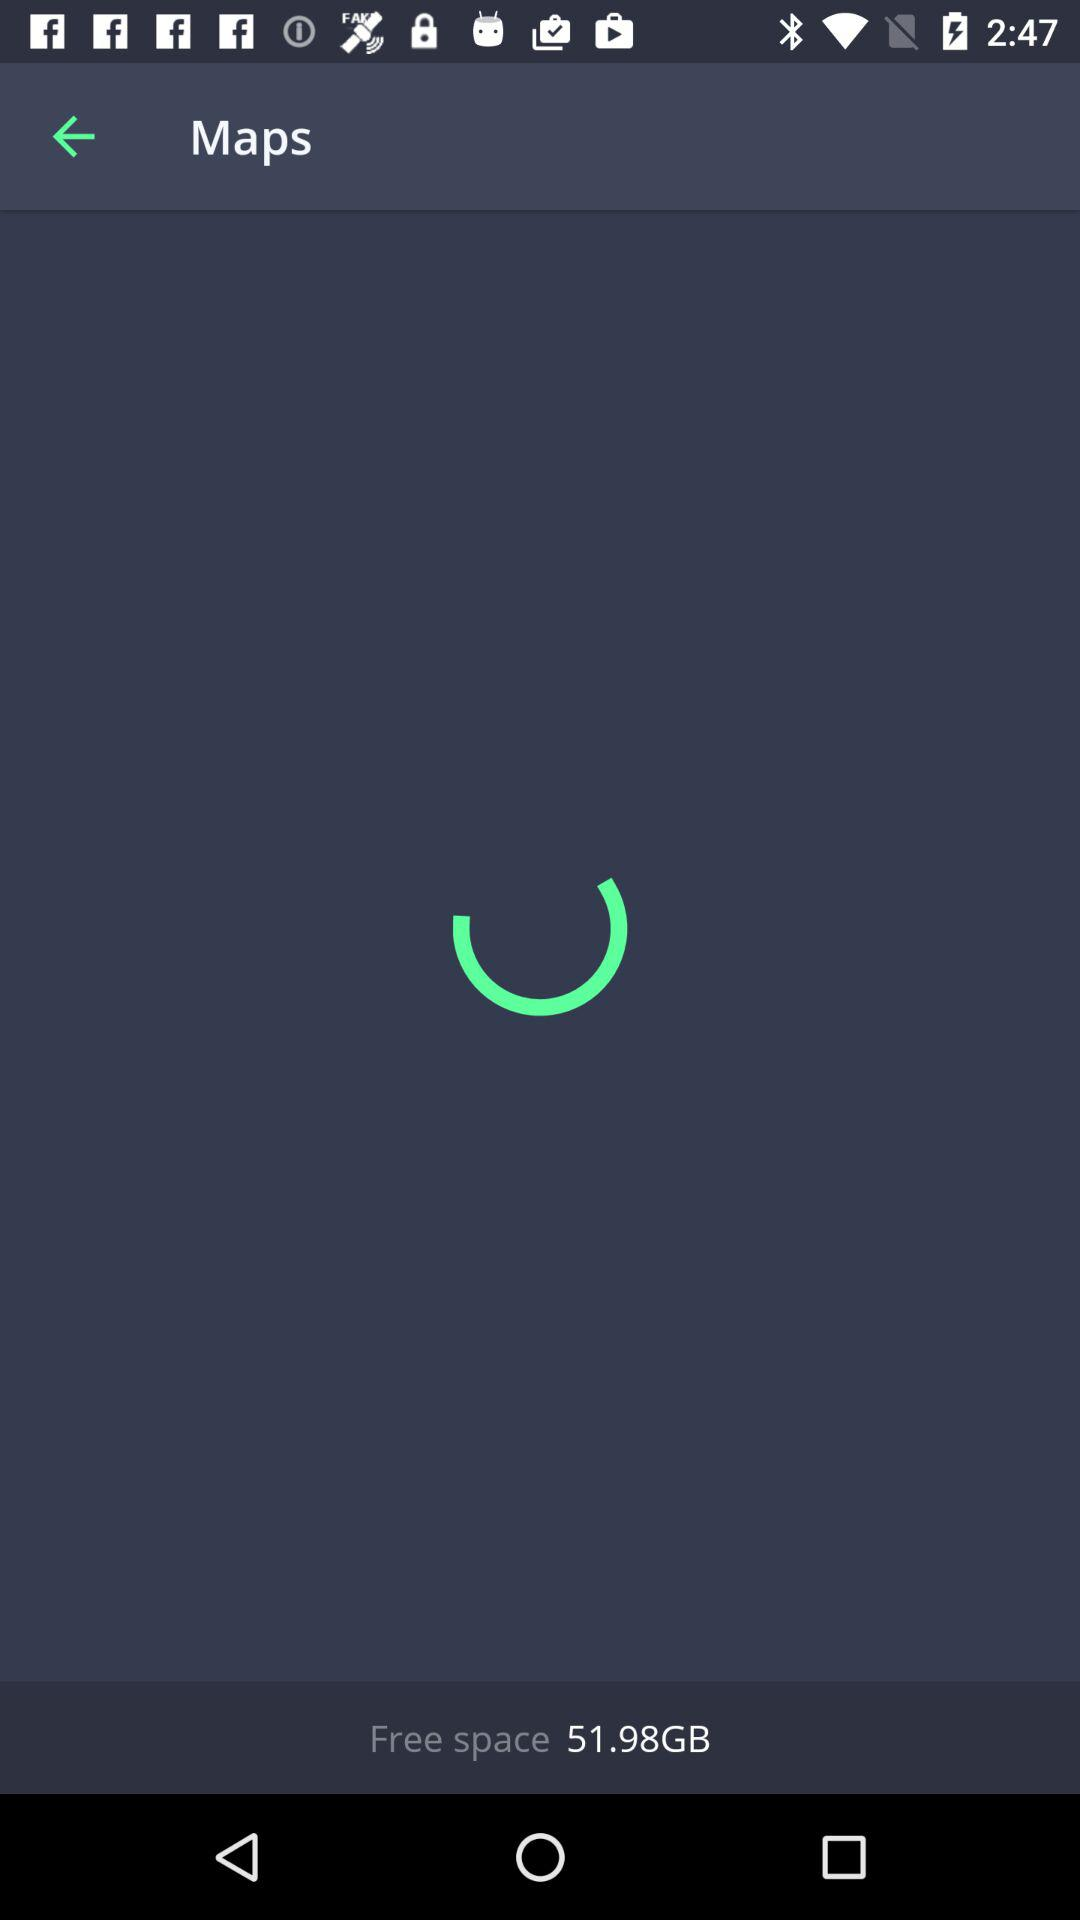How much free space is available on the device?
Answer the question using a single word or phrase. 51.98GB 